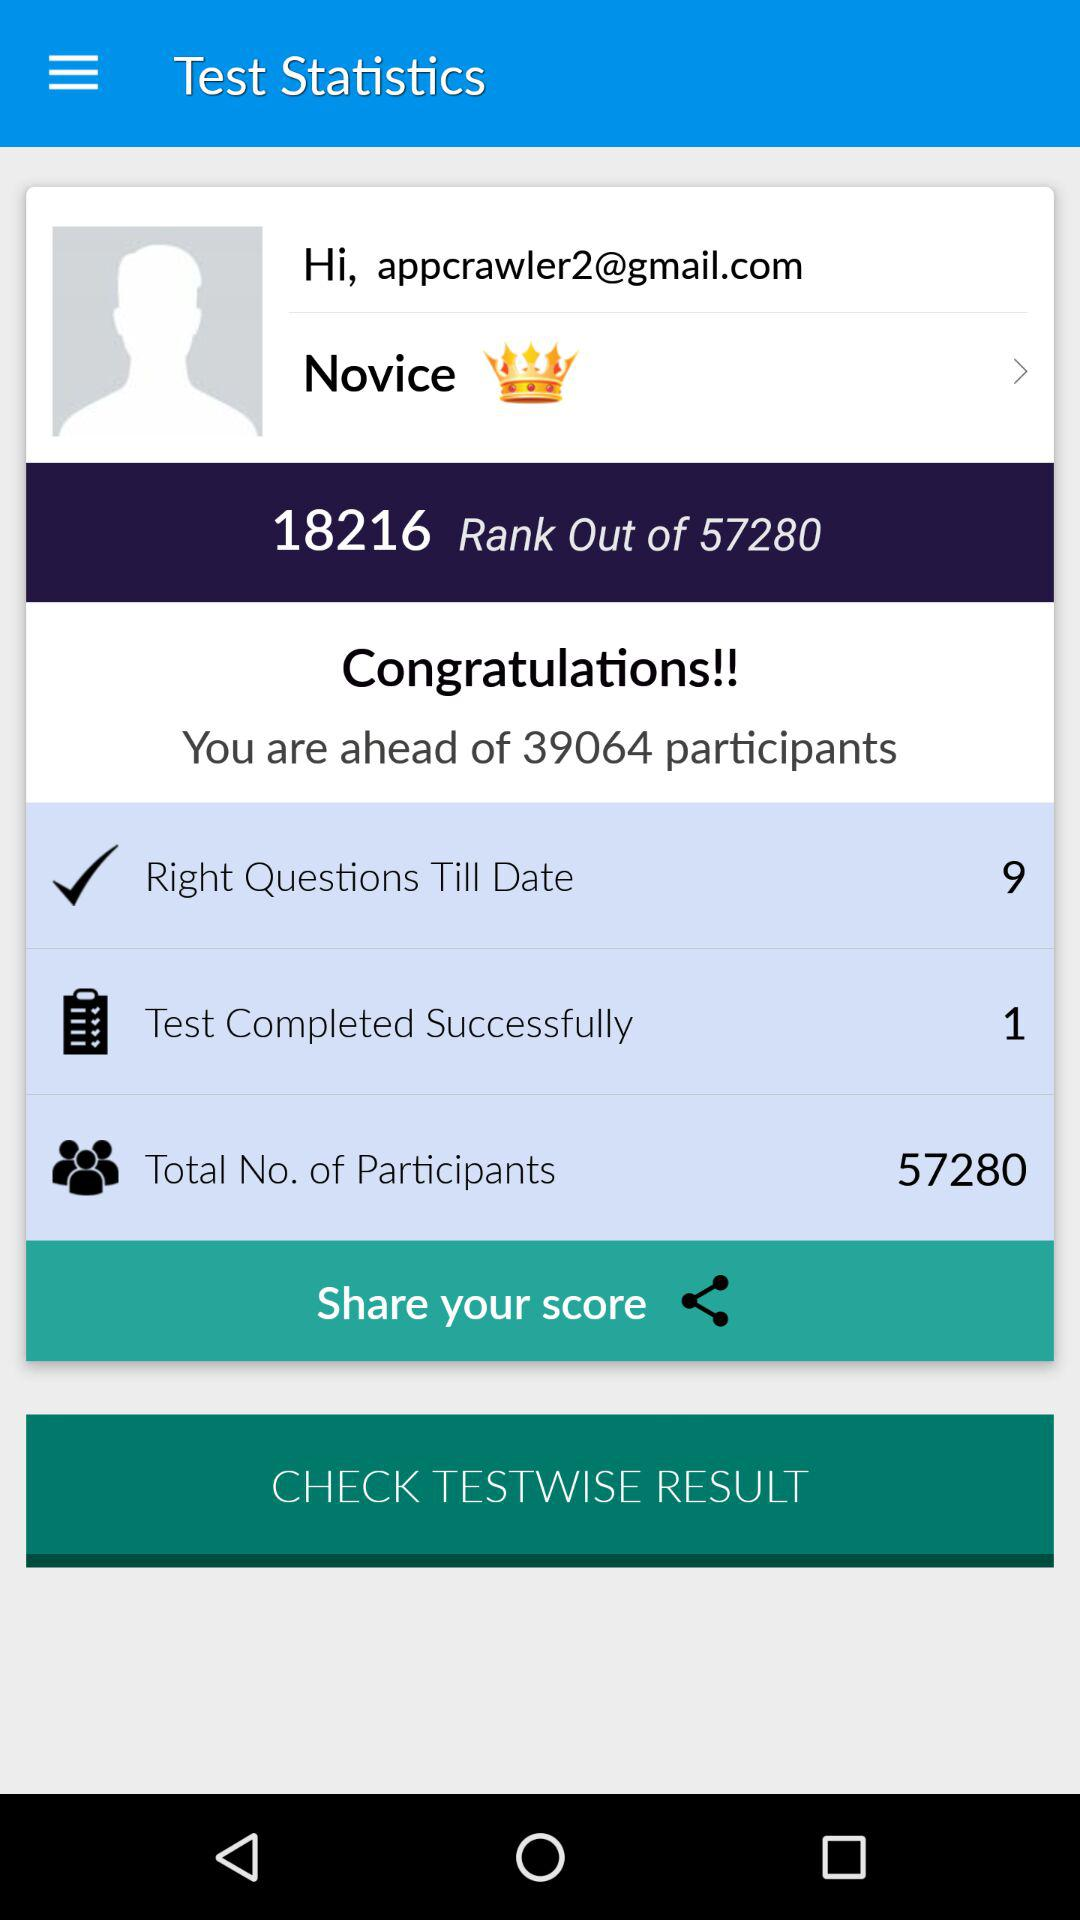What is the user name? The user name is Novice. 